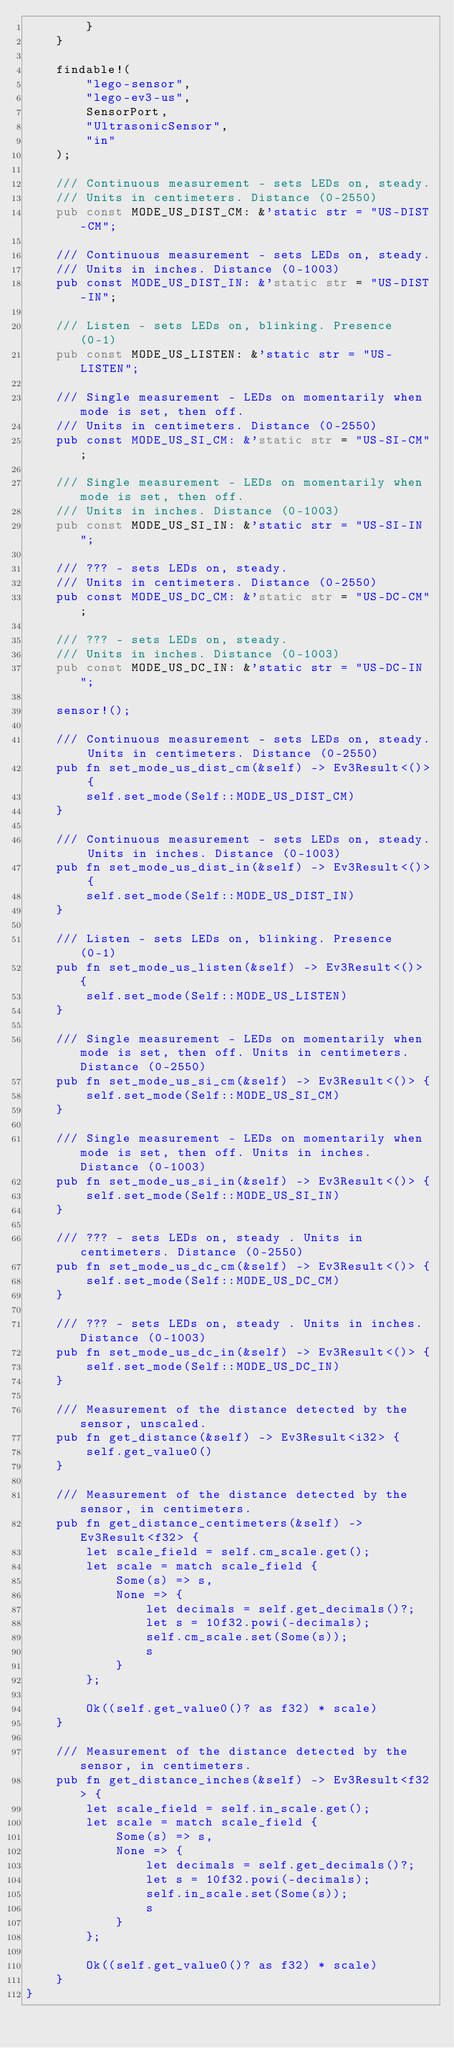Convert code to text. <code><loc_0><loc_0><loc_500><loc_500><_Rust_>        }
    }

    findable!(
        "lego-sensor",
        "lego-ev3-us",
        SensorPort,
        "UltrasonicSensor",
        "in"
    );

    /// Continuous measurement - sets LEDs on, steady.
    /// Units in centimeters. Distance (0-2550)
    pub const MODE_US_DIST_CM: &'static str = "US-DIST-CM";

    /// Continuous measurement - sets LEDs on, steady.
    /// Units in inches. Distance (0-1003)
    pub const MODE_US_DIST_IN: &'static str = "US-DIST-IN";

    /// Listen - sets LEDs on, blinking. Presence (0-1)
    pub const MODE_US_LISTEN: &'static str = "US-LISTEN";

    /// Single measurement - LEDs on momentarily when mode is set, then off.
    /// Units in centimeters. Distance (0-2550)
    pub const MODE_US_SI_CM: &'static str = "US-SI-CM";

    /// Single measurement - LEDs on momentarily when mode is set, then off.
    /// Units in inches. Distance (0-1003)
    pub const MODE_US_SI_IN: &'static str = "US-SI-IN";

    /// ??? - sets LEDs on, steady.
    /// Units in centimeters. Distance (0-2550)
    pub const MODE_US_DC_CM: &'static str = "US-DC-CM";

    /// ??? - sets LEDs on, steady.
    /// Units in inches. Distance (0-1003)
    pub const MODE_US_DC_IN: &'static str = "US-DC-IN";

    sensor!();

    /// Continuous measurement - sets LEDs on, steady. Units in centimeters. Distance (0-2550)
    pub fn set_mode_us_dist_cm(&self) -> Ev3Result<()> {
        self.set_mode(Self::MODE_US_DIST_CM)
    }

    /// Continuous measurement - sets LEDs on, steady. Units in inches. Distance (0-1003)
    pub fn set_mode_us_dist_in(&self) -> Ev3Result<()> {
        self.set_mode(Self::MODE_US_DIST_IN)
    }

    /// Listen - sets LEDs on, blinking. Presence (0-1)
    pub fn set_mode_us_listen(&self) -> Ev3Result<()> {
        self.set_mode(Self::MODE_US_LISTEN)
    }

    /// Single measurement - LEDs on momentarily when mode is set, then off. Units in centimeters. Distance (0-2550)
    pub fn set_mode_us_si_cm(&self) -> Ev3Result<()> {
        self.set_mode(Self::MODE_US_SI_CM)
    }

    /// Single measurement - LEDs on momentarily when mode is set, then off. Units in inches. Distance (0-1003)
    pub fn set_mode_us_si_in(&self) -> Ev3Result<()> {
        self.set_mode(Self::MODE_US_SI_IN)
    }

    /// ??? - sets LEDs on, steady . Units in centimeters. Distance (0-2550)
    pub fn set_mode_us_dc_cm(&self) -> Ev3Result<()> {
        self.set_mode(Self::MODE_US_DC_CM)
    }

    /// ??? - sets LEDs on, steady . Units in inches. Distance (0-1003)
    pub fn set_mode_us_dc_in(&self) -> Ev3Result<()> {
        self.set_mode(Self::MODE_US_DC_IN)
    }

    /// Measurement of the distance detected by the sensor, unscaled.
    pub fn get_distance(&self) -> Ev3Result<i32> {
        self.get_value0()
    }

    /// Measurement of the distance detected by the sensor, in centimeters.
    pub fn get_distance_centimeters(&self) -> Ev3Result<f32> {
        let scale_field = self.cm_scale.get();
        let scale = match scale_field {
            Some(s) => s,
            None => {
                let decimals = self.get_decimals()?;
                let s = 10f32.powi(-decimals);
                self.cm_scale.set(Some(s));
                s
            }
        };

        Ok((self.get_value0()? as f32) * scale)
    }

    /// Measurement of the distance detected by the sensor, in centimeters.
    pub fn get_distance_inches(&self) -> Ev3Result<f32> {
        let scale_field = self.in_scale.get();
        let scale = match scale_field {
            Some(s) => s,
            None => {
                let decimals = self.get_decimals()?;
                let s = 10f32.powi(-decimals);
                self.in_scale.set(Some(s));
                s
            }
        };

        Ok((self.get_value0()? as f32) * scale)
    }
}
</code> 